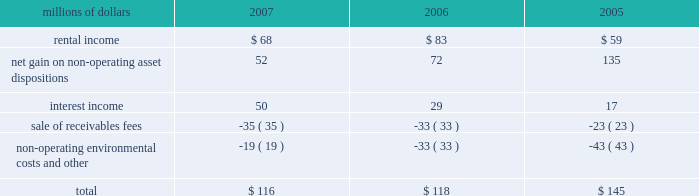Be resolved , we cannot reasonably determine the probability of an adverse claim or reasonably estimate any adverse liability or the total maximum exposure under these indemnification arrangements .
We do not have any reason to believe that we will be required to make any material payments under these indemnity provisions .
Income taxes 2013 as discussed in note 4 , the irs has completed its examinations and issued notices of deficiency for tax years 1995 through 2004 , and we are in different stages of the irs appeals process for these years .
The irs is examining our tax returns for tax years 2005 and 2006 .
In the third quarter of 2007 , we believe that we reached an agreement in principle with the irs to resolve all of the issues , except interest , related to tax years 1995 through 1998 , including the previously reported dispute over certain donations of property .
We anticipate signing a closing agreement in 2008 .
At december 31 , 2007 , we have recorded a current liability of $ 140 million for tax payments in 2008 related to federal and state income tax examinations .
We do not expect that the ultimate resolution of these examinations will have a material adverse effect on our consolidated financial statements .
11 .
Other income other income included the following for the years ended december 31 : millions of dollars 2007 2006 2005 .
12 .
Share repurchase program on january 30 , 2007 , our board of directors authorized the repurchase of up to 20 million shares of union pacific corporation common stock through the end of 2009 .
Management 2019s assessments of market conditions and other pertinent facts guide the timing and volume of all repurchases .
We expect to fund our common stock repurchases through cash generated from operations , the sale or lease of various operating and non- operating properties , debt issuances , and cash on hand at december 31 , 2007 .
During 2007 , we repurchased approximately 13 million shares under this program at an aggregate purchase price of approximately $ 1.5 billion .
These shares were recorded in treasury stock at cost , which includes any applicable commissions and fees. .
What was the percentage of the total other income in 2007 that was rental income? 
Computations: (68 / 116)
Answer: 0.58621. 